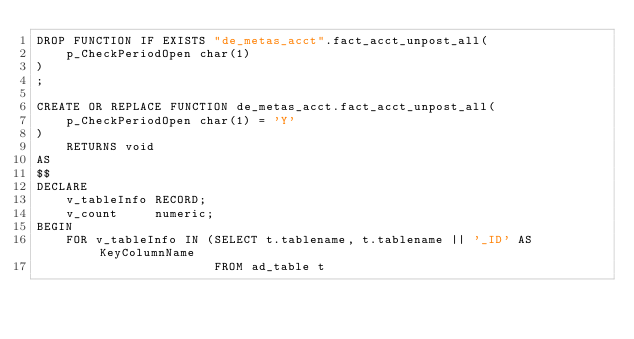Convert code to text. <code><loc_0><loc_0><loc_500><loc_500><_SQL_>DROP FUNCTION IF EXISTS "de_metas_acct".fact_acct_unpost_all(
    p_CheckPeriodOpen char(1)
)
;

CREATE OR REPLACE FUNCTION de_metas_acct.fact_acct_unpost_all(
    p_CheckPeriodOpen char(1) = 'Y'
)
    RETURNS void
AS
$$
DECLARE
    v_tableInfo RECORD;
    v_count     numeric;
BEGIN
    FOR v_tableInfo IN (SELECT t.tablename, t.tablename || '_ID' AS KeyColumnName
                        FROM ad_table t</code> 